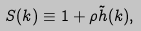Convert formula to latex. <formula><loc_0><loc_0><loc_500><loc_500>S ( { k } ) \equiv 1 + \rho { \tilde { h } } ( { k } ) ,</formula> 